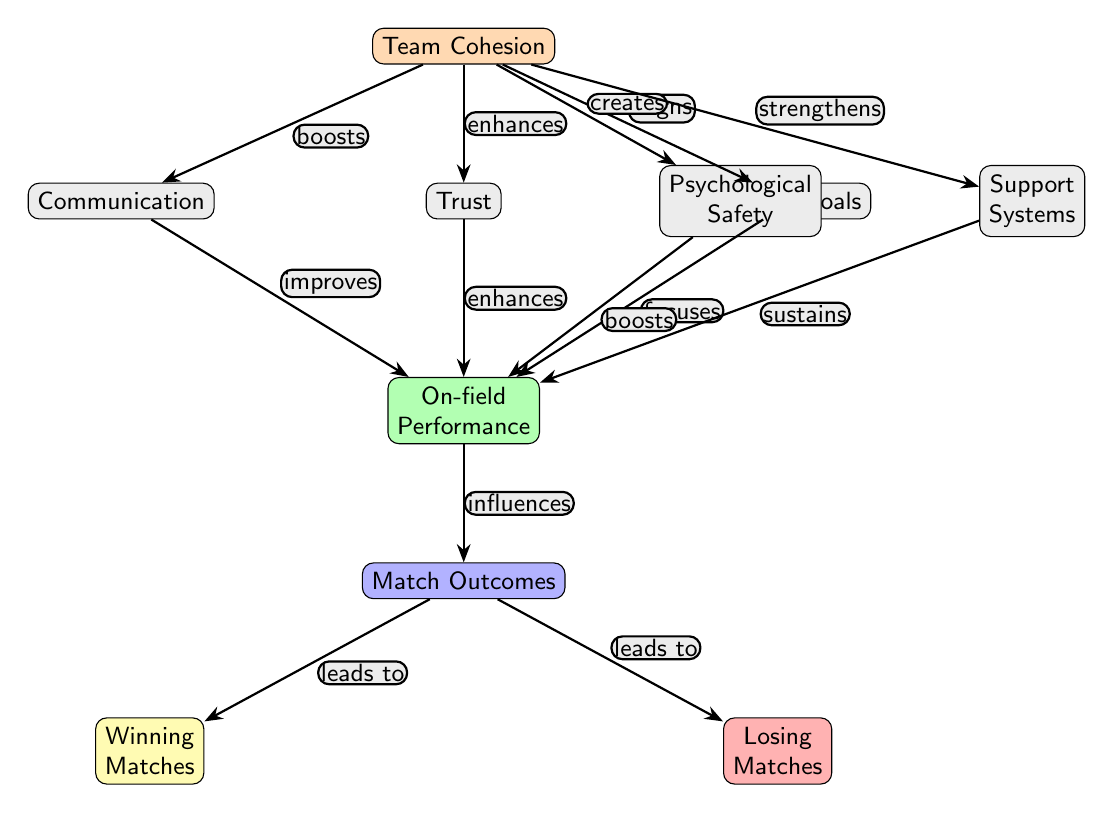What is the main node in the diagram? The main node is "Team Cohesion," which is centrally located and connects to various other nodes representing its influences.
Answer: Team Cohesion How many nodes are there in total? Counting the main node and all dependent nodes, there are 9 nodes represented in the diagram.
Answer: 9 What influence does communication have on on-field performance? The edge labeled "improves" shows that communication positively affects on-field performance, indicating that better communication enhances team performance.
Answer: improves Which node is directly influenced by psychological safety? The diagram shows that psychological safety creates a positive effect on the on-field performance node, reinforcing its importance in boosting performance.
Answer: On-field Performance What do winning matches lead to? The diagram indicates that winning matches is a consequence of favorable match outcomes, represented by the edge labeled "leads to."
Answer: Match Outcomes How many influences does Team Cohesion have on other elements? Team Cohesion has five distinct influences on other nodes, indicating its multifaceted role in team dynamics and performance.
Answer: 5 What is the relationship between on-field performance and match outcomes? The edge labeled "influences" indicates that on-field performance significantly impacts the match outcomes, showing a direct correlation.
Answer: influences What is the color indicating on-field performance? The color assigned to the on-field performance node is green, suggesting a positive or favorable aspect in the context of the diagram.
Answer: green What is the position of shared goals in relation to team cohesion? Shared goals are positioned below and to the right of team cohesion, indicating it is one of the factors strongly related to team dynamics.
Answer: below right 